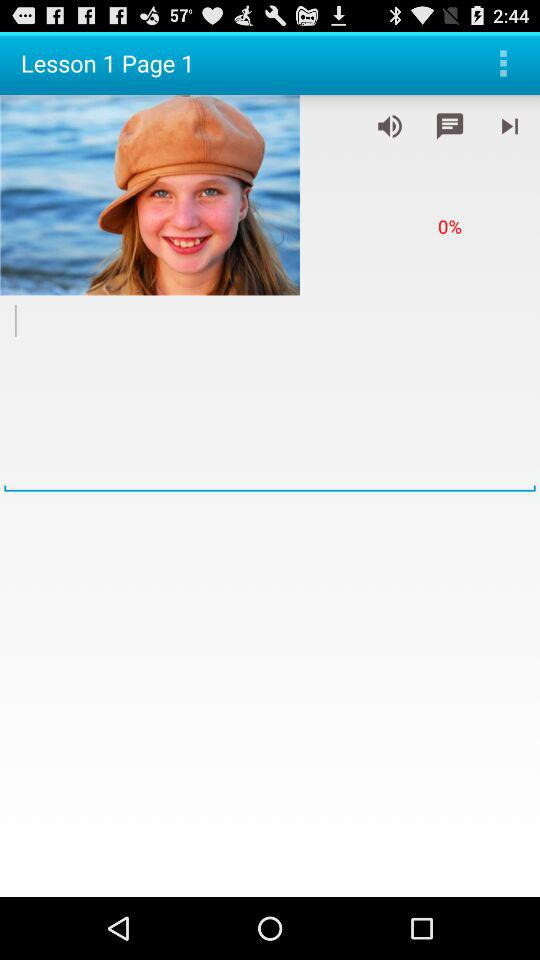What is the current page number? The current page number is 1. 